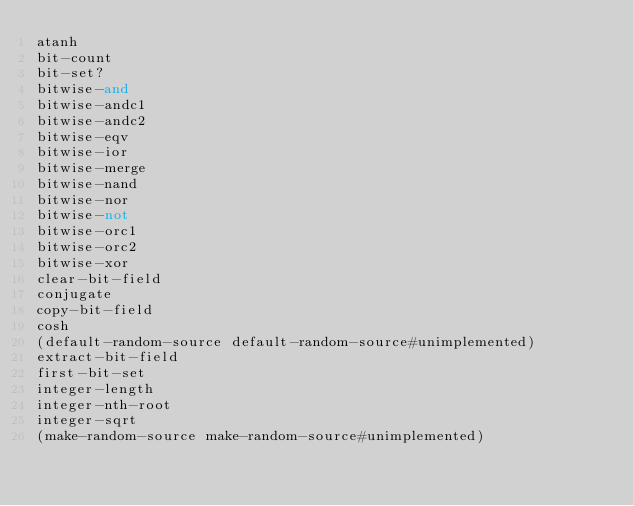<code> <loc_0><loc_0><loc_500><loc_500><_Scheme_>atanh
bit-count
bit-set?
bitwise-and
bitwise-andc1
bitwise-andc2
bitwise-eqv
bitwise-ior
bitwise-merge
bitwise-nand
bitwise-nor
bitwise-not
bitwise-orc1
bitwise-orc2
bitwise-xor
clear-bit-field
conjugate
copy-bit-field
cosh
(default-random-source default-random-source#unimplemented)
extract-bit-field
first-bit-set
integer-length
integer-nth-root
integer-sqrt
(make-random-source make-random-source#unimplemented)</code> 